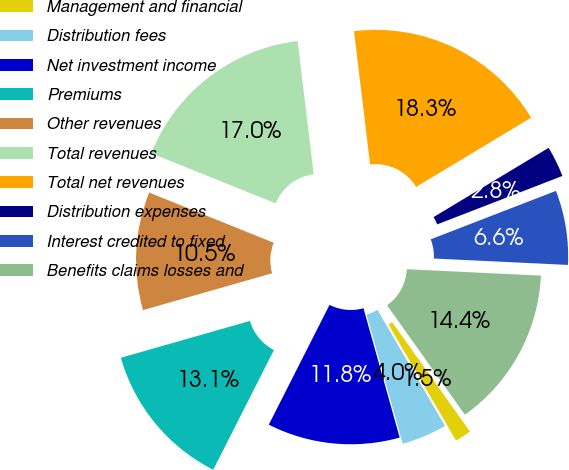<chart> <loc_0><loc_0><loc_500><loc_500><pie_chart><fcel>Management and financial<fcel>Distribution fees<fcel>Net investment income<fcel>Premiums<fcel>Other revenues<fcel>Total revenues<fcel>Total net revenues<fcel>Distribution expenses<fcel>Interest credited to fixed<fcel>Benefits claims losses and<nl><fcel>1.46%<fcel>4.04%<fcel>11.81%<fcel>13.11%<fcel>10.52%<fcel>16.99%<fcel>18.29%<fcel>2.75%<fcel>6.63%<fcel>14.4%<nl></chart> 